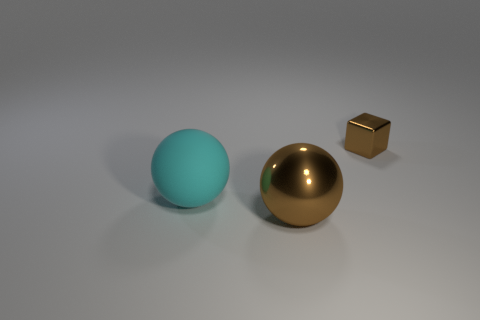There is a large shiny ball; are there any brown cubes on the right side of it?
Ensure brevity in your answer.  Yes. Are there an equal number of blocks behind the brown shiny block and tiny red objects?
Ensure brevity in your answer.  Yes. The other object that is the same size as the matte thing is what shape?
Offer a very short reply. Sphere. What is the material of the big brown sphere?
Provide a succinct answer. Metal. There is a object that is behind the large metallic sphere and on the left side of the tiny brown cube; what is its color?
Offer a terse response. Cyan. Are there an equal number of objects in front of the metallic ball and big brown objects that are on the right side of the big cyan sphere?
Keep it short and to the point. No. The large thing that is made of the same material as the block is what color?
Provide a short and direct response. Brown. Is the color of the metal sphere the same as the ball that is behind the big brown object?
Provide a short and direct response. No. There is a brown metal cube that is right of the metallic object on the left side of the cube; is there a brown metal thing that is on the left side of it?
Your answer should be very brief. Yes. There is a large brown thing that is the same material as the small thing; what shape is it?
Your answer should be compact. Sphere. 